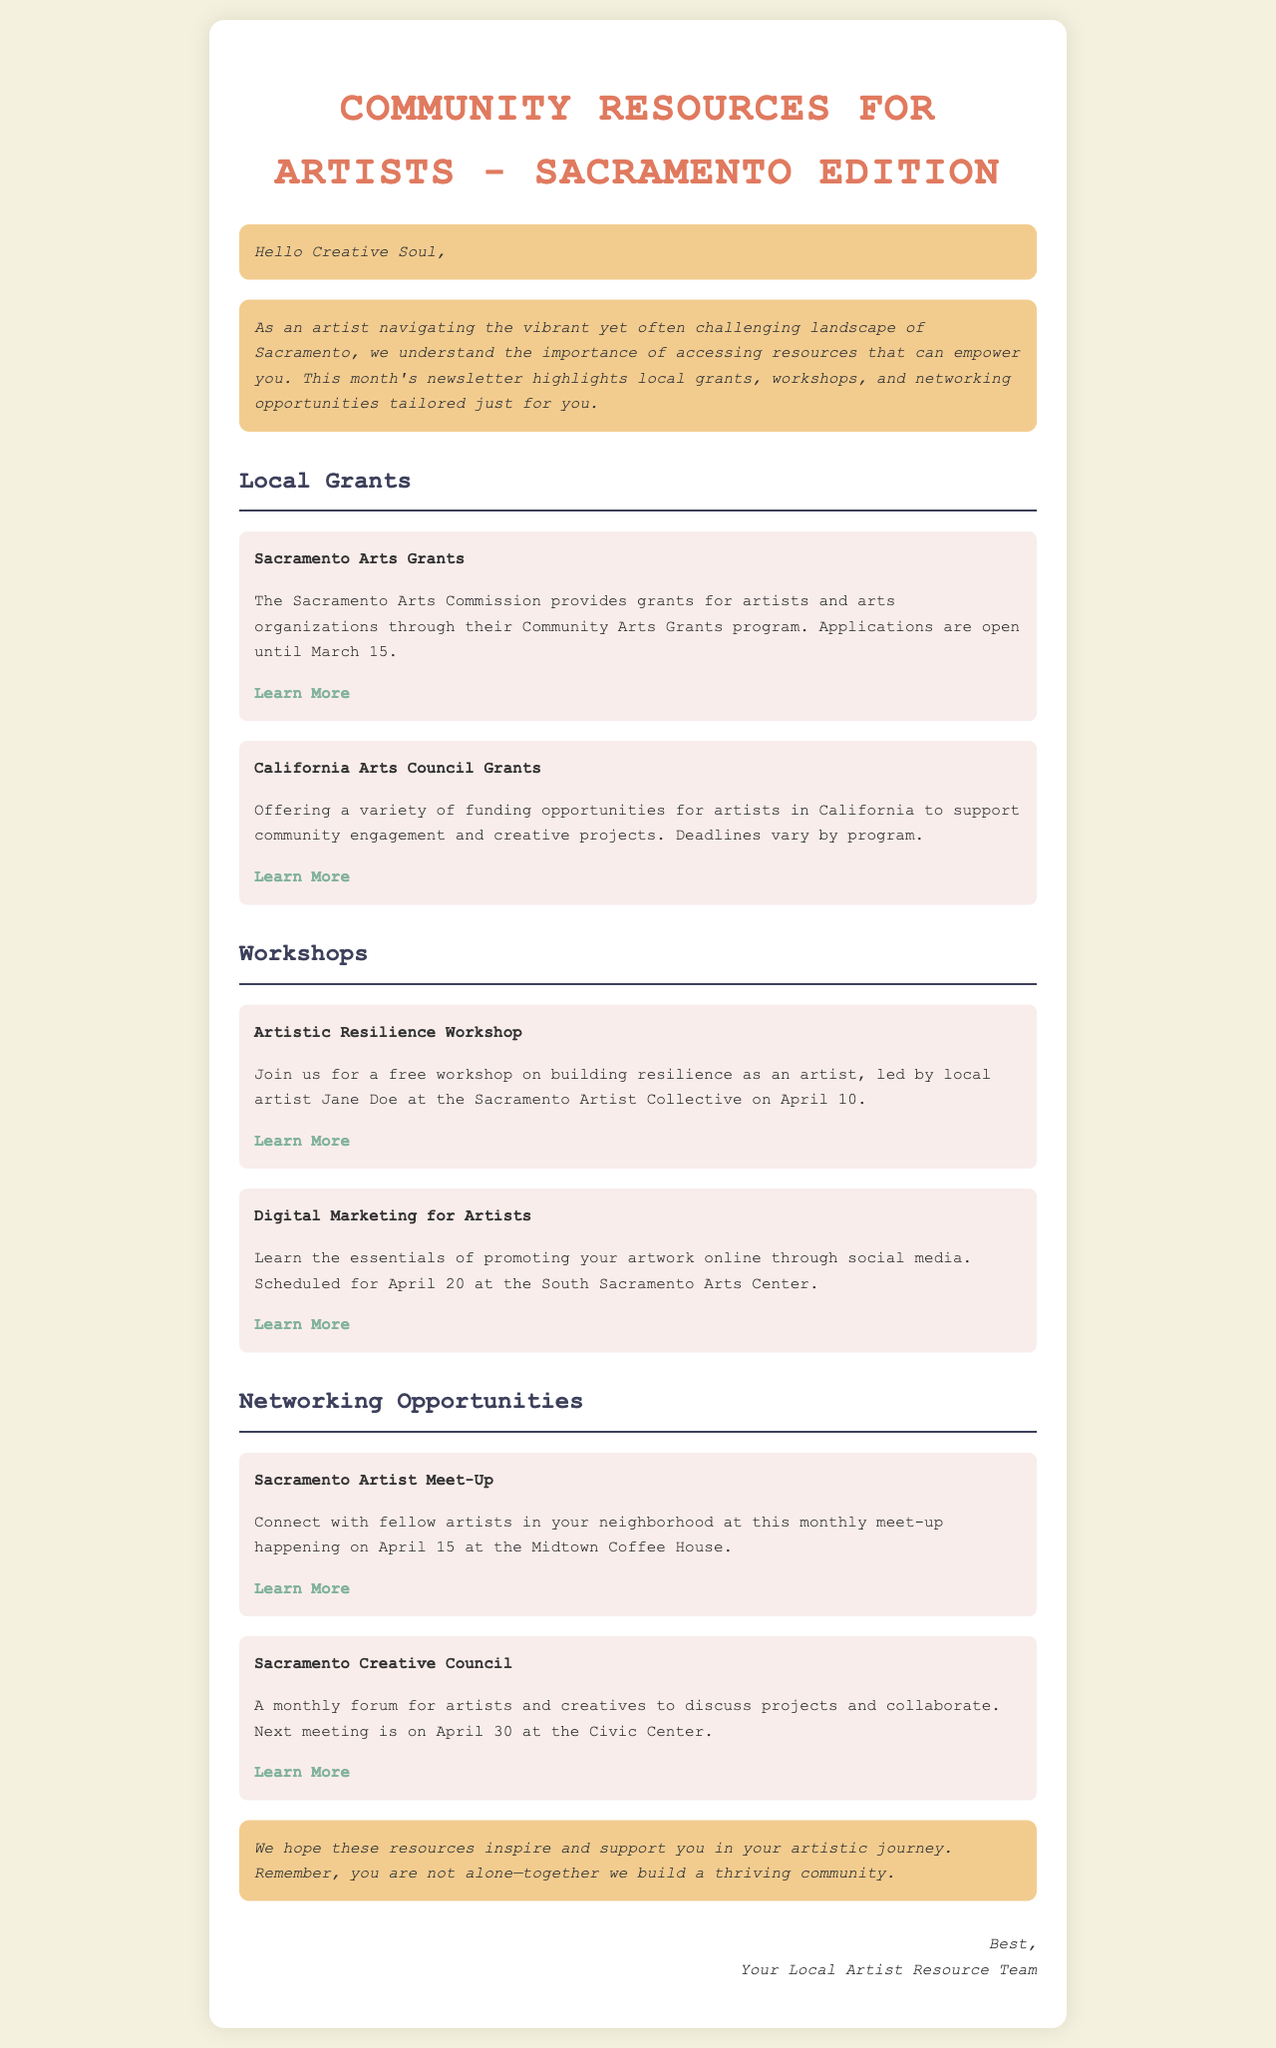What is the title of the newsletter? The title is found in the header of the document.
Answer: Community Resources for Artists - Sacramento Edition When is the application deadline for the Sacramento Arts Grants? The deadline is mentioned in the local grants section of the document.
Answer: March 15 Who is leading the Artistic Resilience Workshop? The workshop details include the instructor's name.
Answer: Jane Doe What date is the Sacramento Artist Meet-Up scheduled for? The meet-up date is provided in the networking opportunities section.
Answer: April 15 What type of funding does the California Arts Council Grants provide? The type of funding is described in the local grants section.
Answer: Variety of funding opportunities How often does the Sacramento Creative Council meet? The frequency of meetings is implied in the document.
Answer: Monthly Where will the Digital Marketing for Artists workshop take place? The location is outlined in the workshop section.
Answer: South Sacramento Arts Center What is the main purpose of the newsletter? The purpose is stated in the introductory paragraph.
Answer: Accessing resources for artists What color is used for the section headers? The specific color can be inferred from the document's styling.
Answer: #3d405b What type of resource does the newsletter highlight? The types of resources are listed in the document's sections.
Answer: Grants, workshops, networking opportunities 